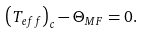<formula> <loc_0><loc_0><loc_500><loc_500>\left ( T _ { e f f } \right ) _ { c } - \Theta _ { M F } = 0 .</formula> 